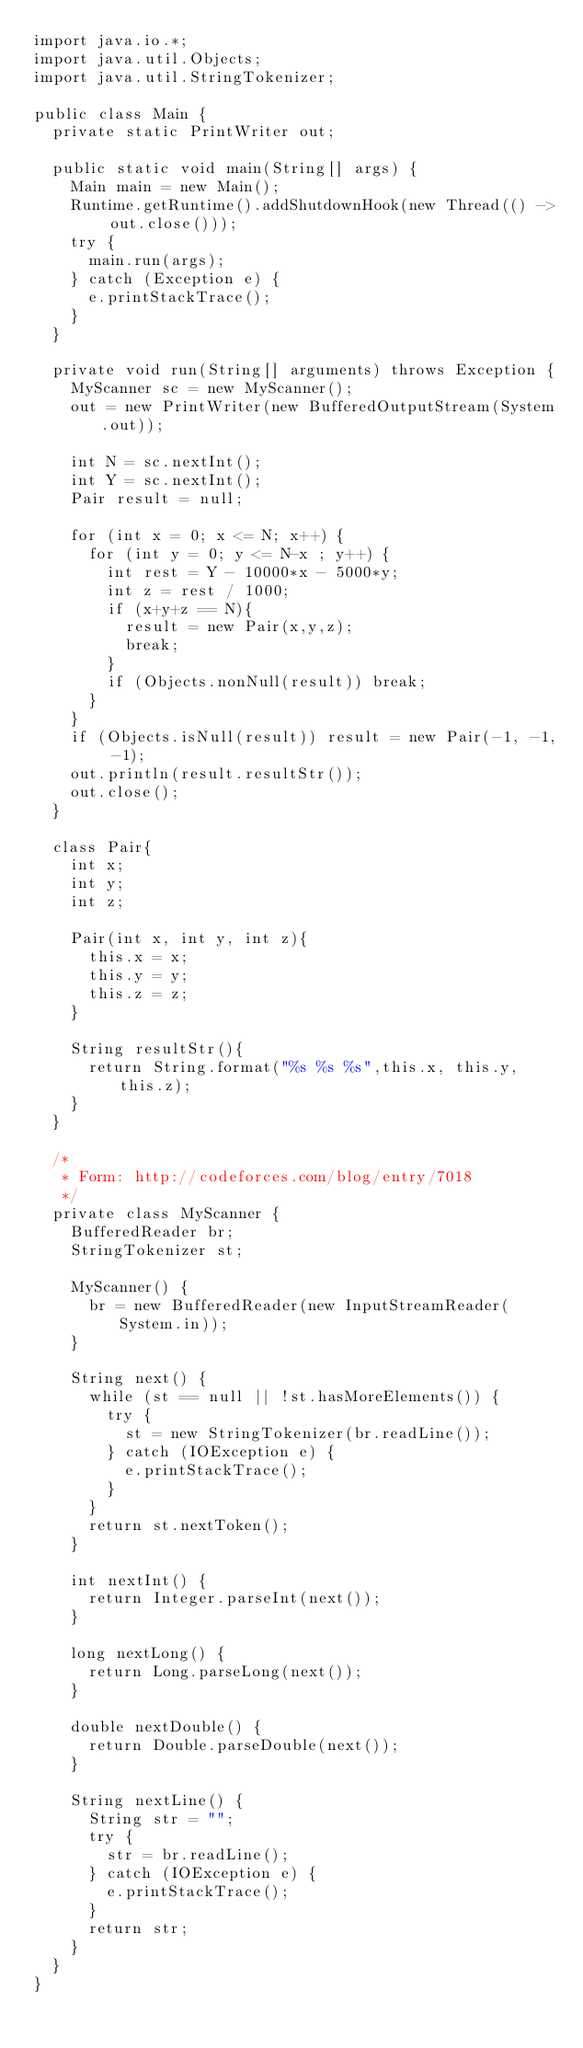<code> <loc_0><loc_0><loc_500><loc_500><_Java_>import java.io.*;
import java.util.Objects;
import java.util.StringTokenizer;

public class Main {
  private static PrintWriter out;

  public static void main(String[] args) {
    Main main = new Main();
    Runtime.getRuntime().addShutdownHook(new Thread(() -> out.close()));
    try {
      main.run(args);
    } catch (Exception e) {
      e.printStackTrace();
    }
  }

  private void run(String[] arguments) throws Exception {
    MyScanner sc = new MyScanner();
    out = new PrintWriter(new BufferedOutputStream(System.out));

    int N = sc.nextInt();
    int Y = sc.nextInt();
    Pair result = null;

    for (int x = 0; x <= N; x++) {
      for (int y = 0; y <= N-x ; y++) {
        int rest = Y - 10000*x - 5000*y;
        int z = rest / 1000;
        if (x+y+z == N){
          result = new Pair(x,y,z);
          break;
        }
        if (Objects.nonNull(result)) break;
      }
    }
    if (Objects.isNull(result)) result = new Pair(-1, -1, -1);
    out.println(result.resultStr());
    out.close();
  }

  class Pair{
    int x;
    int y;
    int z;
    
    Pair(int x, int y, int z){
      this.x = x;
      this.y = y;
      this.z = z;
    }

    String resultStr(){
      return String.format("%s %s %s",this.x, this.y, this.z);
    }
  }

  /*          
   * Form: http://codeforces.com/blog/entry/7018
   */
  private class MyScanner {
    BufferedReader br;
    StringTokenizer st;

    MyScanner() {
      br = new BufferedReader(new InputStreamReader(System.in));
    }

    String next() {
      while (st == null || !st.hasMoreElements()) {
        try {
          st = new StringTokenizer(br.readLine());
        } catch (IOException e) {
          e.printStackTrace();
        }
      }
      return st.nextToken();
    }

    int nextInt() {
      return Integer.parseInt(next());
    }

    long nextLong() {
      return Long.parseLong(next());
    }

    double nextDouble() {
      return Double.parseDouble(next());
    }

    String nextLine() {
      String str = "";
      try {
        str = br.readLine();
      } catch (IOException e) {
        e.printStackTrace();
      }
      return str;
    }
  }
}
</code> 